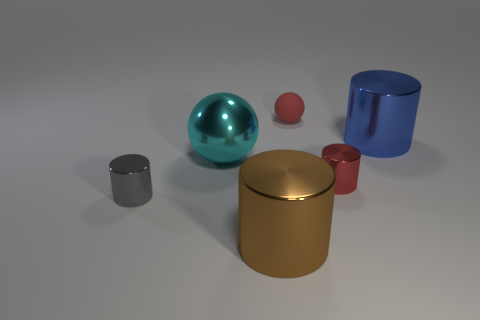Add 2 small red balls. How many objects exist? 8 Subtract all big brown metal cylinders. How many cylinders are left? 3 Subtract 2 balls. How many balls are left? 0 Subtract all small gray cubes. Subtract all red metallic objects. How many objects are left? 5 Add 6 brown things. How many brown things are left? 7 Add 1 yellow objects. How many yellow objects exist? 1 Subtract all cyan balls. How many balls are left? 1 Subtract 0 yellow cylinders. How many objects are left? 6 Subtract all spheres. How many objects are left? 4 Subtract all yellow balls. Subtract all cyan blocks. How many balls are left? 2 